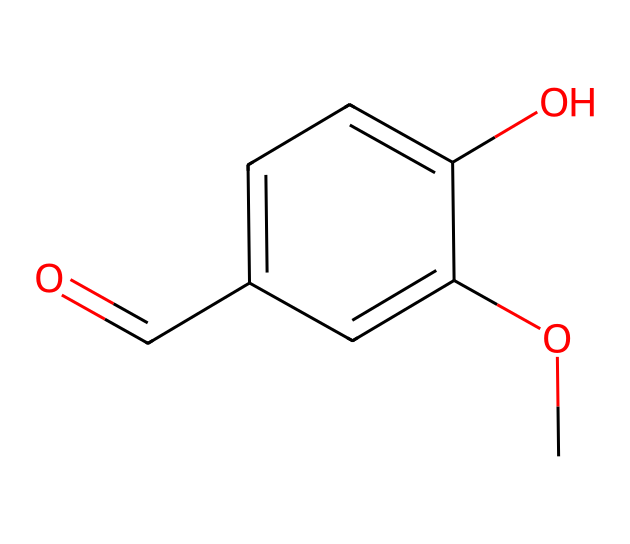What is the molecular formula of vanillin? The molecular formula can be derived from the structure by counting the different types of atoms present: there are 8 carbon (C) atoms, 8 hydrogen (H) atoms, and 3 oxygen (O) atoms. This gives us the formula C8H8O3.
Answer: C8H8O3 How many aromatic rings are present in vanillin? By examining the structure, it can be observed that there is one benzene ring present, which is characteristic of aromatic compounds.
Answer: 1 What functional groups are present in vanillin? The structure shows a hydroxyl group (-OH) and an aldehyde group (-CHO), which are key functional groups in this compound. Hydroxyl is shown directly attached to the aromatic ring and aldehyde is at the end of the carbon chain.
Answer: hydroxyl and aldehyde What is the primary aroma characteristic of vanillin? Based on its structure and common usage, vanillin is known for its distinctive sweet, vanilla-like aroma, which is a result of the presence of the aldehyde and methoxy functional groups.
Answer: vanilla How does the methoxy group influence the flavor profile of vanillin? The methoxy group (-OCH3) plays a crucial role in enhancing the sweetness and complexity of the aroma, making it more appealing and defining its use in flavoring and fragrances.
Answer: enhances sweetness What type of compound is vanillin classified as? Vanillin is classified as a phenolic compound due to the presence of the aromatic ring and the hydroxyl functional group, which contributes to its flavor and fragrance properties.
Answer: phenolic compound Why is vanillin commonly used in sports-themed air fresheners? Vanillin is utilized because of its pleasant vanilla aroma which evokes a sense of freshness and warmth, making it popular for creating an inviting atmosphere, suitable for environments such as cars and gyms.
Answer: pleasant vanilla aroma 